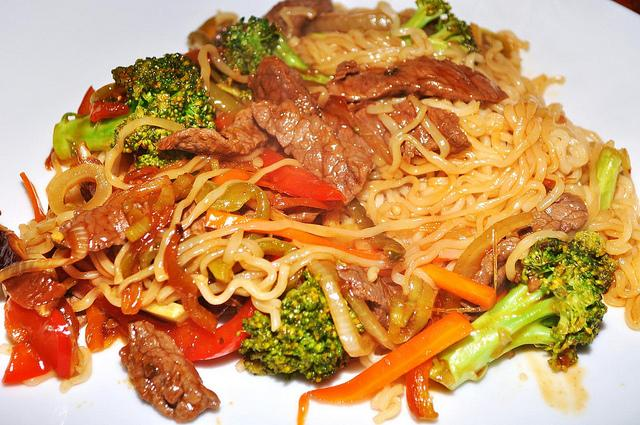What is touching the broccoli? Please explain your reasoning. pasta noodles. The pasta touches the broccoli. 